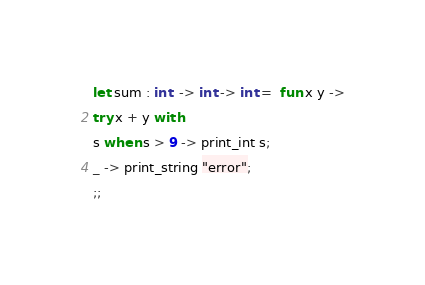<code> <loc_0><loc_0><loc_500><loc_500><_OCaml_>let sum : int  -> int -> int =  fun x y ->
try x + y with
s when s > 9 -> print_int s;
_ -> print_string "error";
;;</code> 